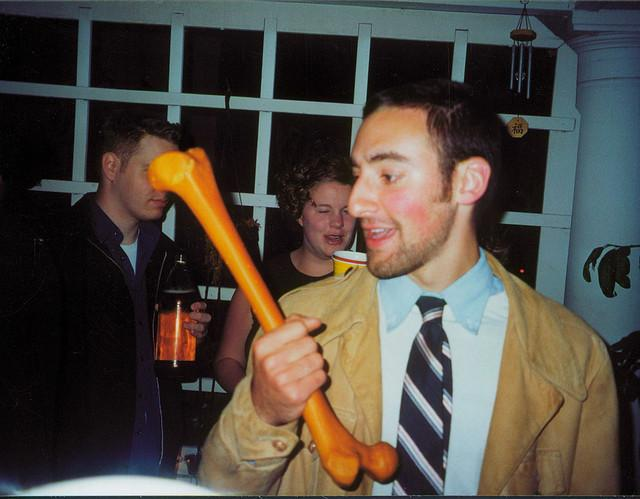What is the orange object called? bone 